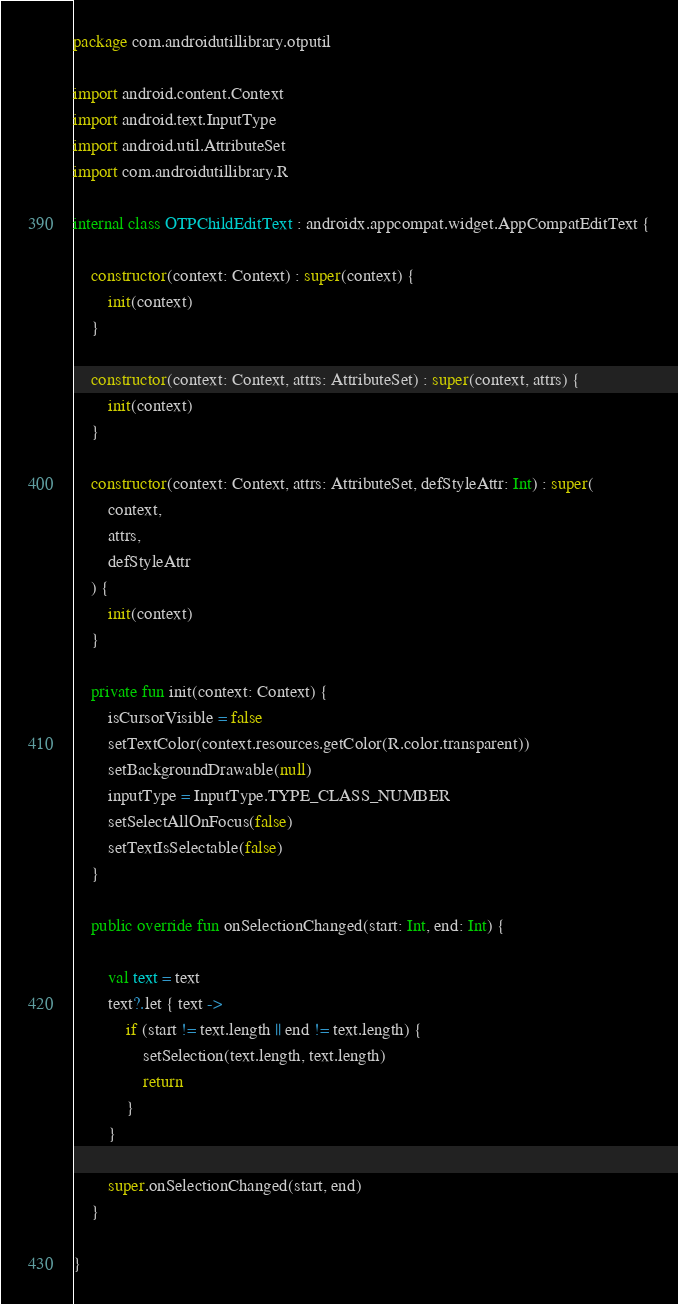Convert code to text. <code><loc_0><loc_0><loc_500><loc_500><_Kotlin_>package com.androidutillibrary.otputil

import android.content.Context
import android.text.InputType
import android.util.AttributeSet
import com.androidutillibrary.R

internal class OTPChildEditText : androidx.appcompat.widget.AppCompatEditText {

    constructor(context: Context) : super(context) {
        init(context)
    }

    constructor(context: Context, attrs: AttributeSet) : super(context, attrs) {
        init(context)
    }

    constructor(context: Context, attrs: AttributeSet, defStyleAttr: Int) : super(
        context,
        attrs,
        defStyleAttr
    ) {
        init(context)
    }

    private fun init(context: Context) {
        isCursorVisible = false
        setTextColor(context.resources.getColor(R.color.transparent))
        setBackgroundDrawable(null)
        inputType = InputType.TYPE_CLASS_NUMBER
        setSelectAllOnFocus(false)
        setTextIsSelectable(false)
    }

    public override fun onSelectionChanged(start: Int, end: Int) {

        val text = text
        text?.let { text ->
            if (start != text.length || end != text.length) {
                setSelection(text.length, text.length)
                return
            }
        }

        super.onSelectionChanged(start, end)
    }

}</code> 